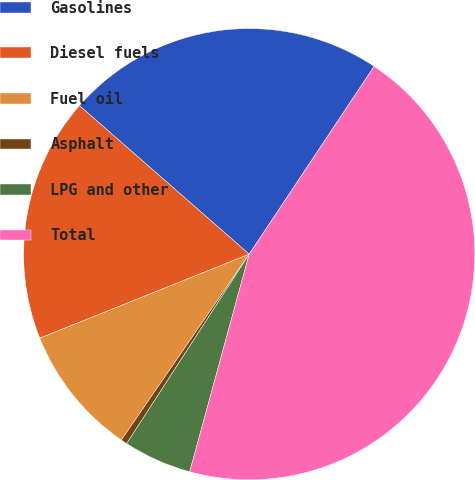Convert chart to OTSL. <chart><loc_0><loc_0><loc_500><loc_500><pie_chart><fcel>Gasolines<fcel>Diesel fuels<fcel>Fuel oil<fcel>Asphalt<fcel>LPG and other<fcel>Total<nl><fcel>22.9%<fcel>17.51%<fcel>9.34%<fcel>0.45%<fcel>4.89%<fcel>44.9%<nl></chart> 